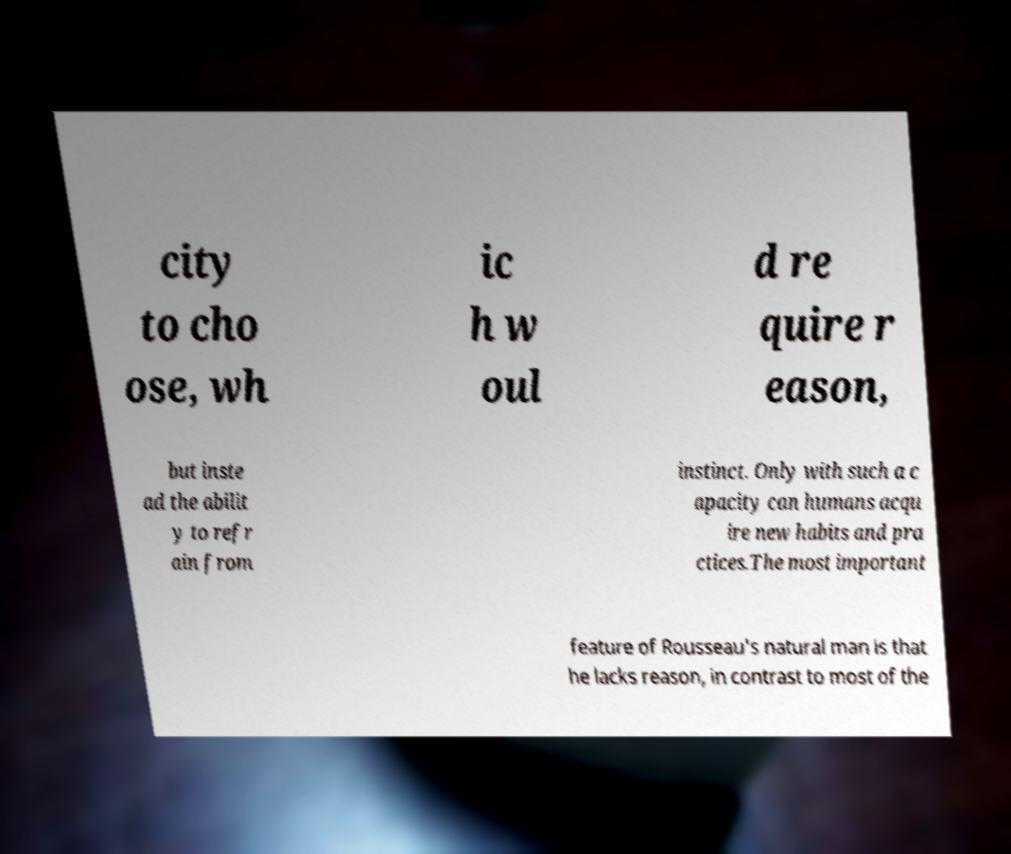I need the written content from this picture converted into text. Can you do that? city to cho ose, wh ic h w oul d re quire r eason, but inste ad the abilit y to refr ain from instinct. Only with such a c apacity can humans acqu ire new habits and pra ctices.The most important feature of Rousseau's natural man is that he lacks reason, in contrast to most of the 